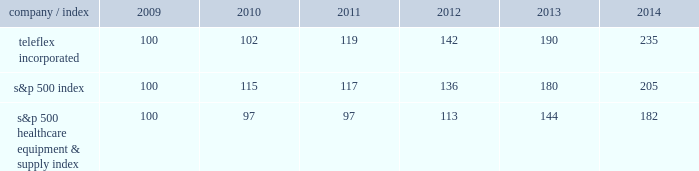Stock performance graph the following graph provides a comparison of five year cumulative total stockholder returns of teleflex common stock , the standard & poor 2019s ( s&p ) 500 stock index and the s&p 500 healthcare equipment & supply index .
The annual changes for the five-year period shown on the graph are based on the assumption that $ 100 had been invested in teleflex common stock and each index on december 31 , 2009 and that all dividends were reinvested .
Market performance .
S&p 500 healthcare equipment & supply index 100 97 97 113 144 182 .
What is the rate of return of an investment in teleflex incorporated from 2009 to 2010? 
Computations: ((102 - 100) / 100)
Answer: 0.02. 